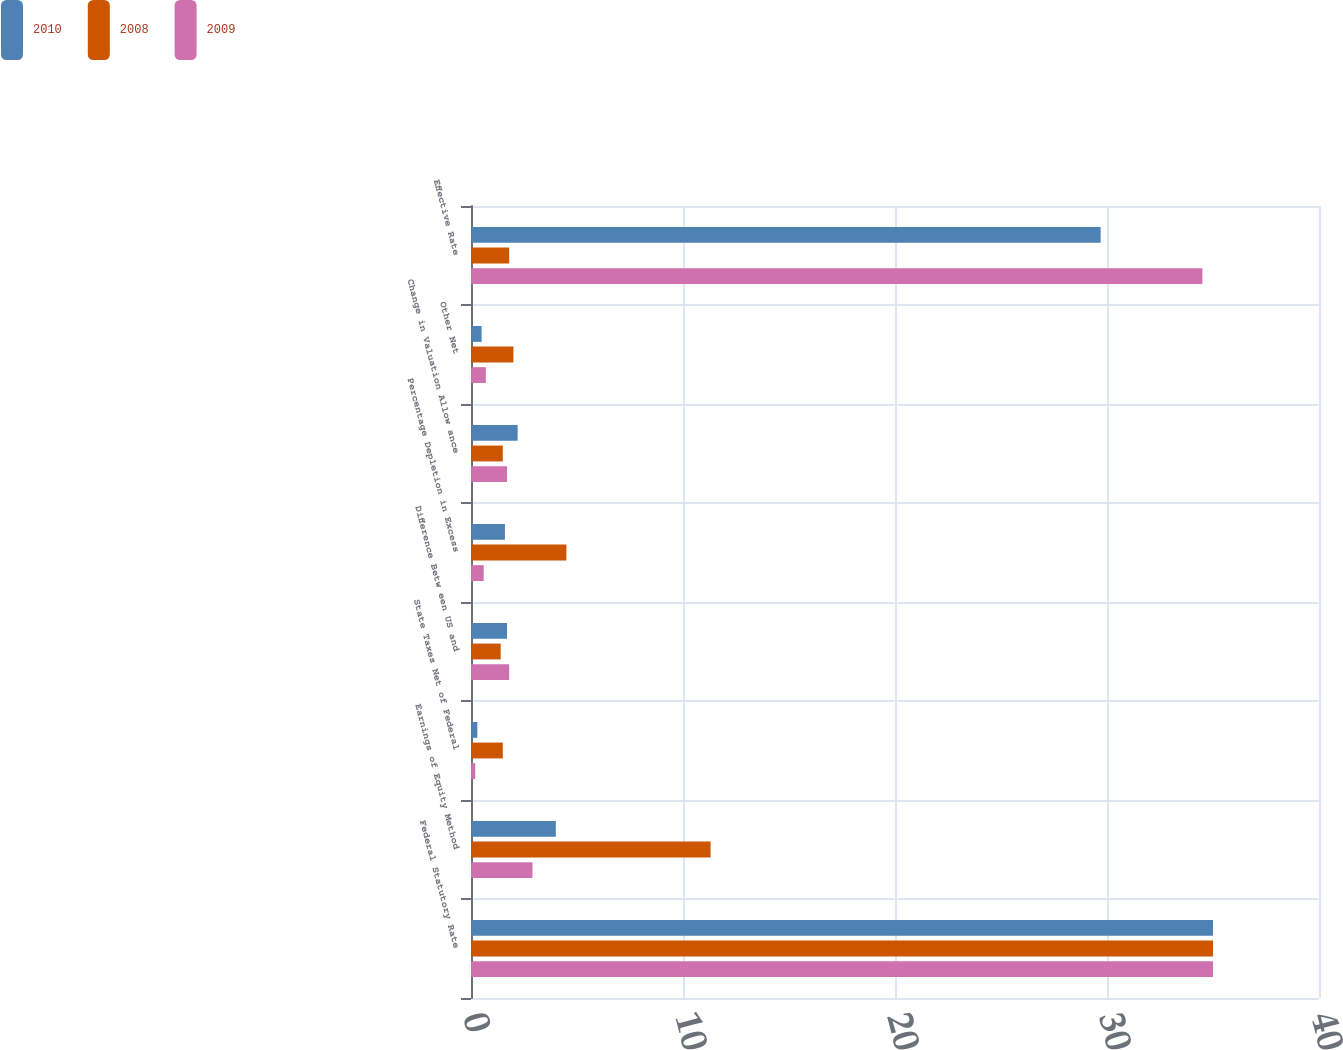<chart> <loc_0><loc_0><loc_500><loc_500><stacked_bar_chart><ecel><fcel>Federal Statutory Rate<fcel>Earnings of Equity Method<fcel>State Taxes Net of Federal<fcel>Difference Betw een US and<fcel>Percentage Depletion in Excess<fcel>Change in Valuation Allow ance<fcel>Other Net<fcel>Effective Rate<nl><fcel>2010<fcel>35<fcel>4<fcel>0.3<fcel>1.7<fcel>1.6<fcel>2.2<fcel>0.5<fcel>29.7<nl><fcel>2008<fcel>35<fcel>11.3<fcel>1.5<fcel>1.4<fcel>4.5<fcel>1.5<fcel>2<fcel>1.8<nl><fcel>2009<fcel>35<fcel>2.9<fcel>0.2<fcel>1.8<fcel>0.6<fcel>1.7<fcel>0.7<fcel>34.5<nl></chart> 